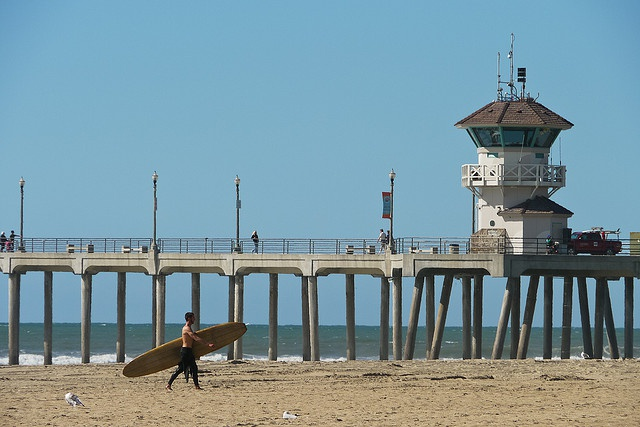Describe the objects in this image and their specific colors. I can see surfboard in gray, black, and olive tones, people in gray, black, maroon, and brown tones, truck in gray, black, and teal tones, people in gray, black, teal, and maroon tones, and people in gray, black, darkgray, and lightblue tones in this image. 